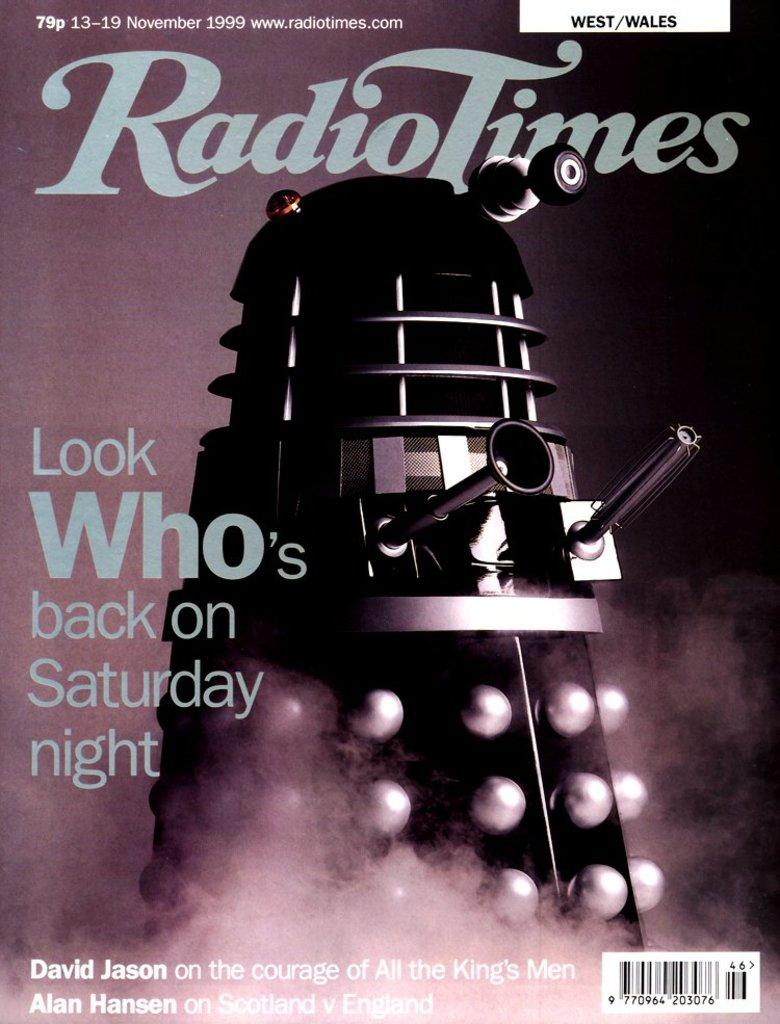<image>
Give a short and clear explanation of the subsequent image. A robot on the cover of Radio Times magazine. 